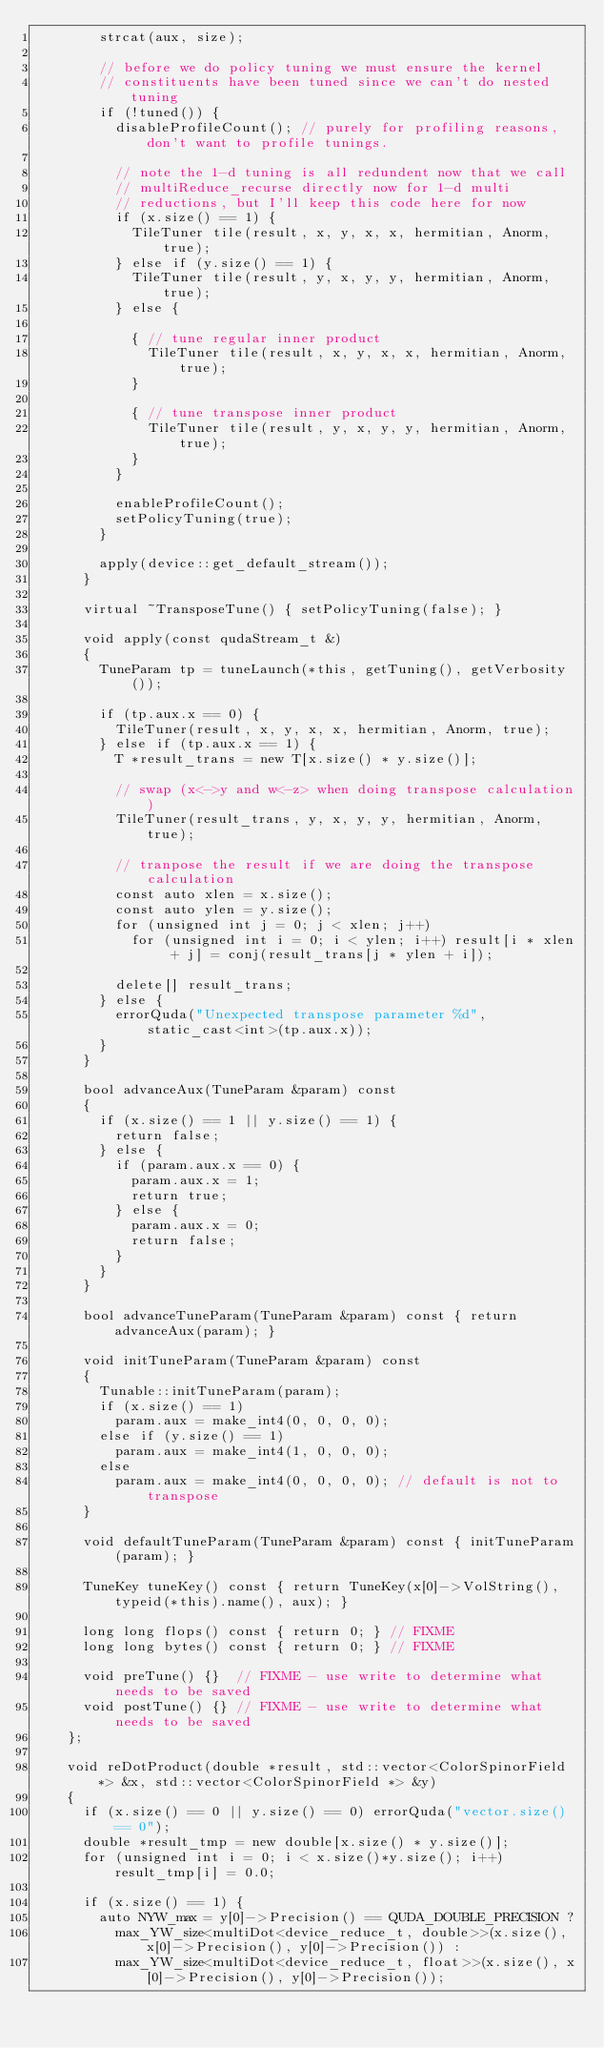<code> <loc_0><loc_0><loc_500><loc_500><_Cuda_>        strcat(aux, size);

        // before we do policy tuning we must ensure the kernel
        // constituents have been tuned since we can't do nested tuning
        if (!tuned()) {
          disableProfileCount(); // purely for profiling reasons, don't want to profile tunings.

          // note the 1-d tuning is all redundent now that we call
          // multiReduce_recurse directly now for 1-d multi
          // reductions, but I'll keep this code here for now
          if (x.size() == 1) {
            TileTuner tile(result, x, y, x, x, hermitian, Anorm, true);
          } else if (y.size() == 1) {
            TileTuner tile(result, y, x, y, y, hermitian, Anorm, true);
          } else {

            { // tune regular inner product
              TileTuner tile(result, x, y, x, x, hermitian, Anorm, true);
            }

            { // tune transpose inner product
              TileTuner tile(result, y, x, y, y, hermitian, Anorm, true);
            }
          }

          enableProfileCount();
          setPolicyTuning(true);
        }

        apply(device::get_default_stream());
      }

      virtual ~TransposeTune() { setPolicyTuning(false); }

      void apply(const qudaStream_t &)
      {
        TuneParam tp = tuneLaunch(*this, getTuning(), getVerbosity());

        if (tp.aux.x == 0) {
          TileTuner(result, x, y, x, x, hermitian, Anorm, true);
        } else if (tp.aux.x == 1) {
          T *result_trans = new T[x.size() * y.size()];

          // swap (x<->y and w<-z> when doing transpose calculation)
          TileTuner(result_trans, y, x, y, y, hermitian, Anorm, true);

          // tranpose the result if we are doing the transpose calculation
          const auto xlen = x.size();
          const auto ylen = y.size();
          for (unsigned int j = 0; j < xlen; j++)
            for (unsigned int i = 0; i < ylen; i++) result[i * xlen + j] = conj(result_trans[j * ylen + i]);

          delete[] result_trans;
        } else {
          errorQuda("Unexpected transpose parameter %d", static_cast<int>(tp.aux.x));
        }
      }

      bool advanceAux(TuneParam &param) const
      {
        if (x.size() == 1 || y.size() == 1) {
          return false;
        } else {
          if (param.aux.x == 0) {
            param.aux.x = 1;
            return true;
          } else {
            param.aux.x = 0;
            return false;
          }
        }
      }

      bool advanceTuneParam(TuneParam &param) const { return advanceAux(param); }

      void initTuneParam(TuneParam &param) const
      {
        Tunable::initTuneParam(param);
        if (x.size() == 1)
          param.aux = make_int4(0, 0, 0, 0);
        else if (y.size() == 1)
          param.aux = make_int4(1, 0, 0, 0);
        else
          param.aux = make_int4(0, 0, 0, 0); // default is not to transpose
      }

      void defaultTuneParam(TuneParam &param) const { initTuneParam(param); }

      TuneKey tuneKey() const { return TuneKey(x[0]->VolString(), typeid(*this).name(), aux); }

      long long flops() const { return 0; } // FIXME
      long long bytes() const { return 0; } // FIXME

      void preTune() {}  // FIXME - use write to determine what needs to be saved
      void postTune() {} // FIXME - use write to determine what needs to be saved
    };

    void reDotProduct(double *result, std::vector<ColorSpinorField *> &x, std::vector<ColorSpinorField *> &y)
    {
      if (x.size() == 0 || y.size() == 0) errorQuda("vector.size() == 0");
      double *result_tmp = new double[x.size() * y.size()];
      for (unsigned int i = 0; i < x.size()*y.size(); i++) result_tmp[i] = 0.0;

      if (x.size() == 1) {
        auto NYW_max = y[0]->Precision() == QUDA_DOUBLE_PRECISION ?
          max_YW_size<multiDot<device_reduce_t, double>>(x.size(), x[0]->Precision(), y[0]->Precision()) :
          max_YW_size<multiDot<device_reduce_t, float>>(x.size(), x[0]->Precision(), y[0]->Precision());
</code> 